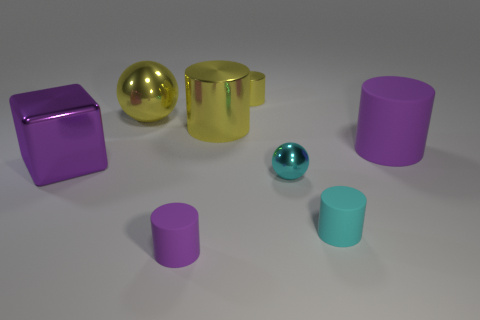What is the shape of the small cyan thing in front of the metal sphere that is to the right of the purple matte thing that is on the left side of the small cyan matte cylinder?
Ensure brevity in your answer.  Cylinder. Are there fewer big purple shiny cubes that are behind the large purple metal cube than purple metallic cubes that are to the left of the big yellow cylinder?
Make the answer very short. Yes. There is a big object that is in front of the big matte object; does it have the same shape as the tiny shiny object behind the big rubber cylinder?
Your answer should be compact. No. What shape is the purple rubber object behind the purple rubber thing that is in front of the large cube?
Your response must be concise. Cylinder. There is a metal sphere that is the same color as the tiny shiny cylinder; what is its size?
Offer a very short reply. Large. Is there another large purple cube made of the same material as the large purple block?
Offer a very short reply. No. There is a large object that is right of the cyan rubber cylinder; what is it made of?
Your response must be concise. Rubber. What is the big yellow cylinder made of?
Provide a succinct answer. Metal. Is the material of the purple cylinder to the left of the cyan matte cylinder the same as the yellow ball?
Your answer should be compact. No. Are there fewer large cubes that are behind the large rubber thing than small gray rubber things?
Ensure brevity in your answer.  No. 